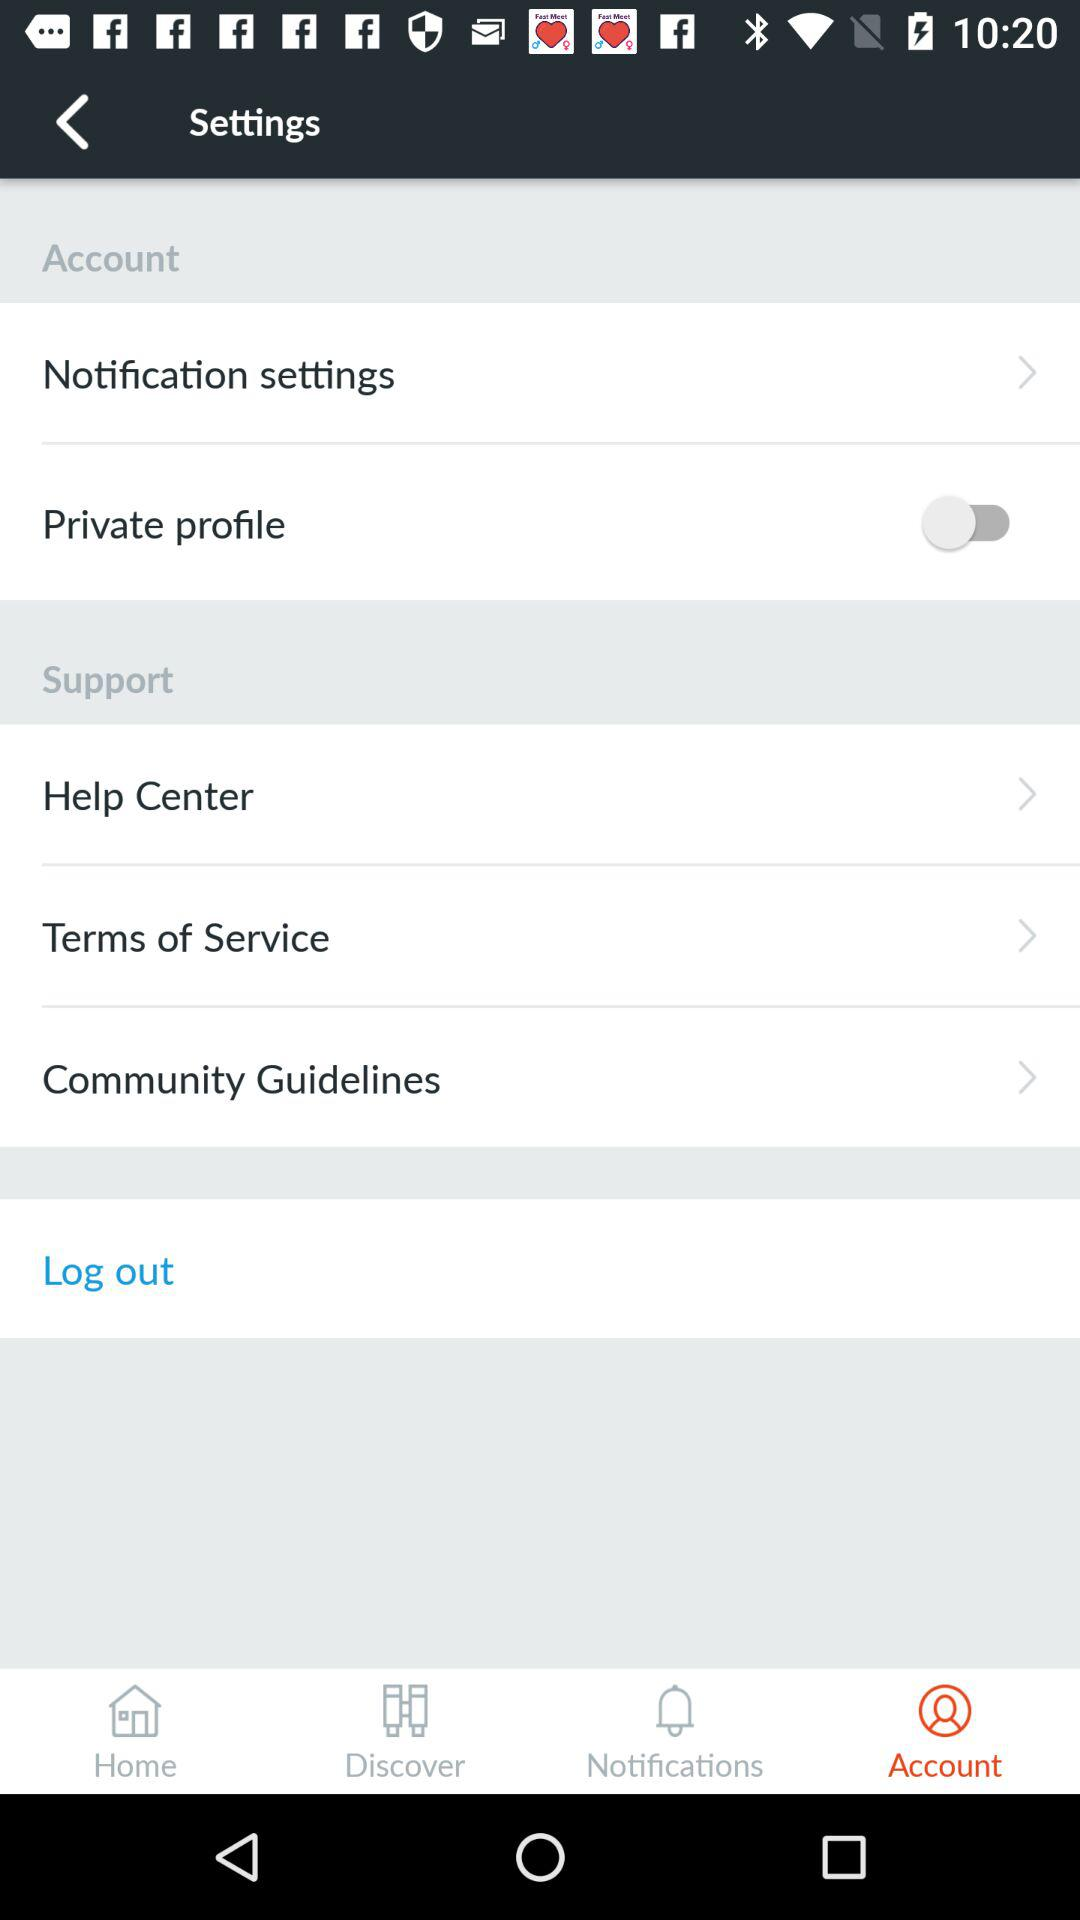Which tab is selected? The tab "Account" is selected. 